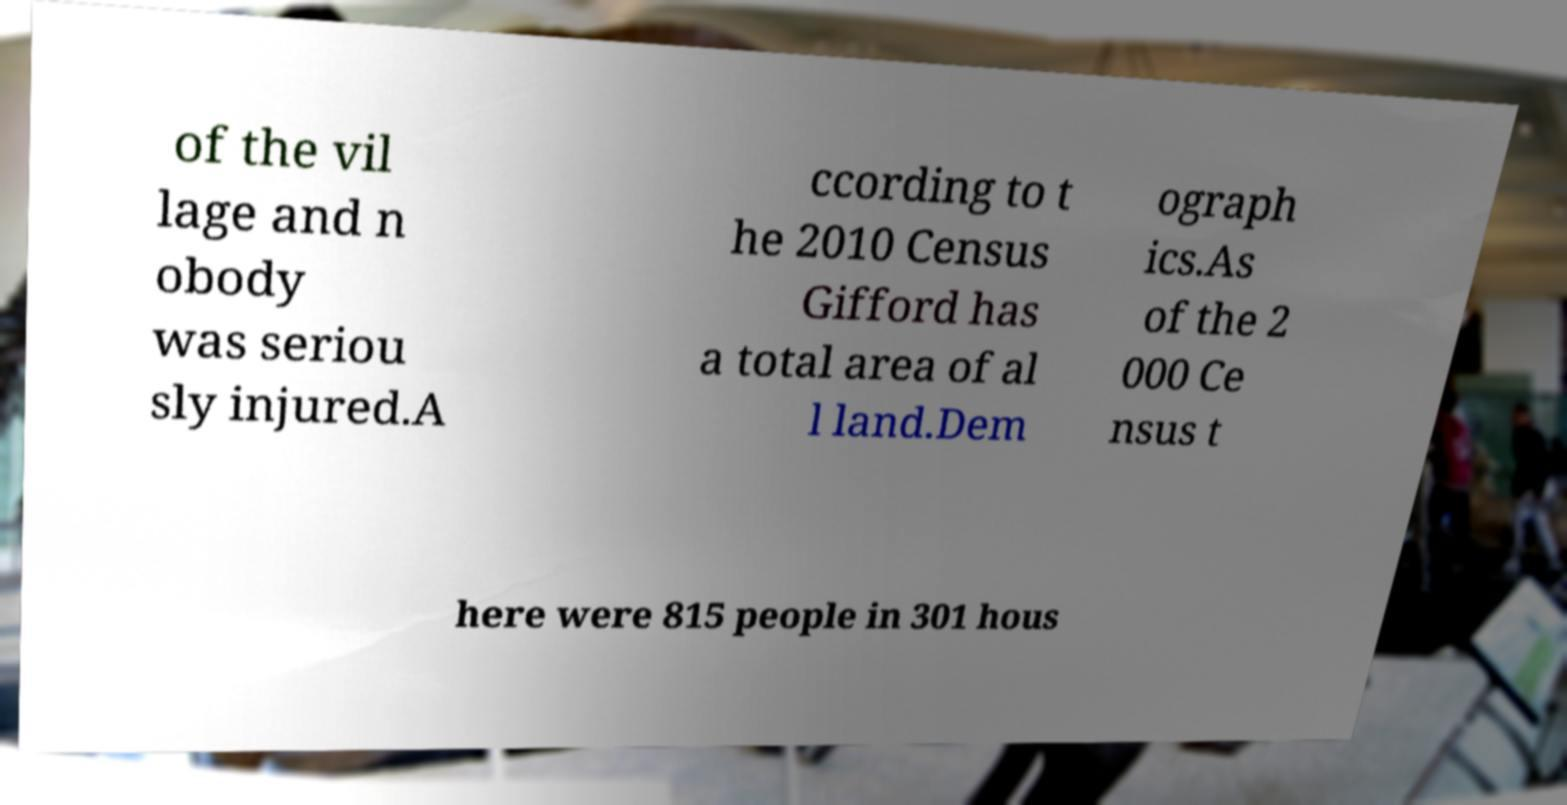Could you assist in decoding the text presented in this image and type it out clearly? of the vil lage and n obody was seriou sly injured.A ccording to t he 2010 Census Gifford has a total area of al l land.Dem ograph ics.As of the 2 000 Ce nsus t here were 815 people in 301 hous 